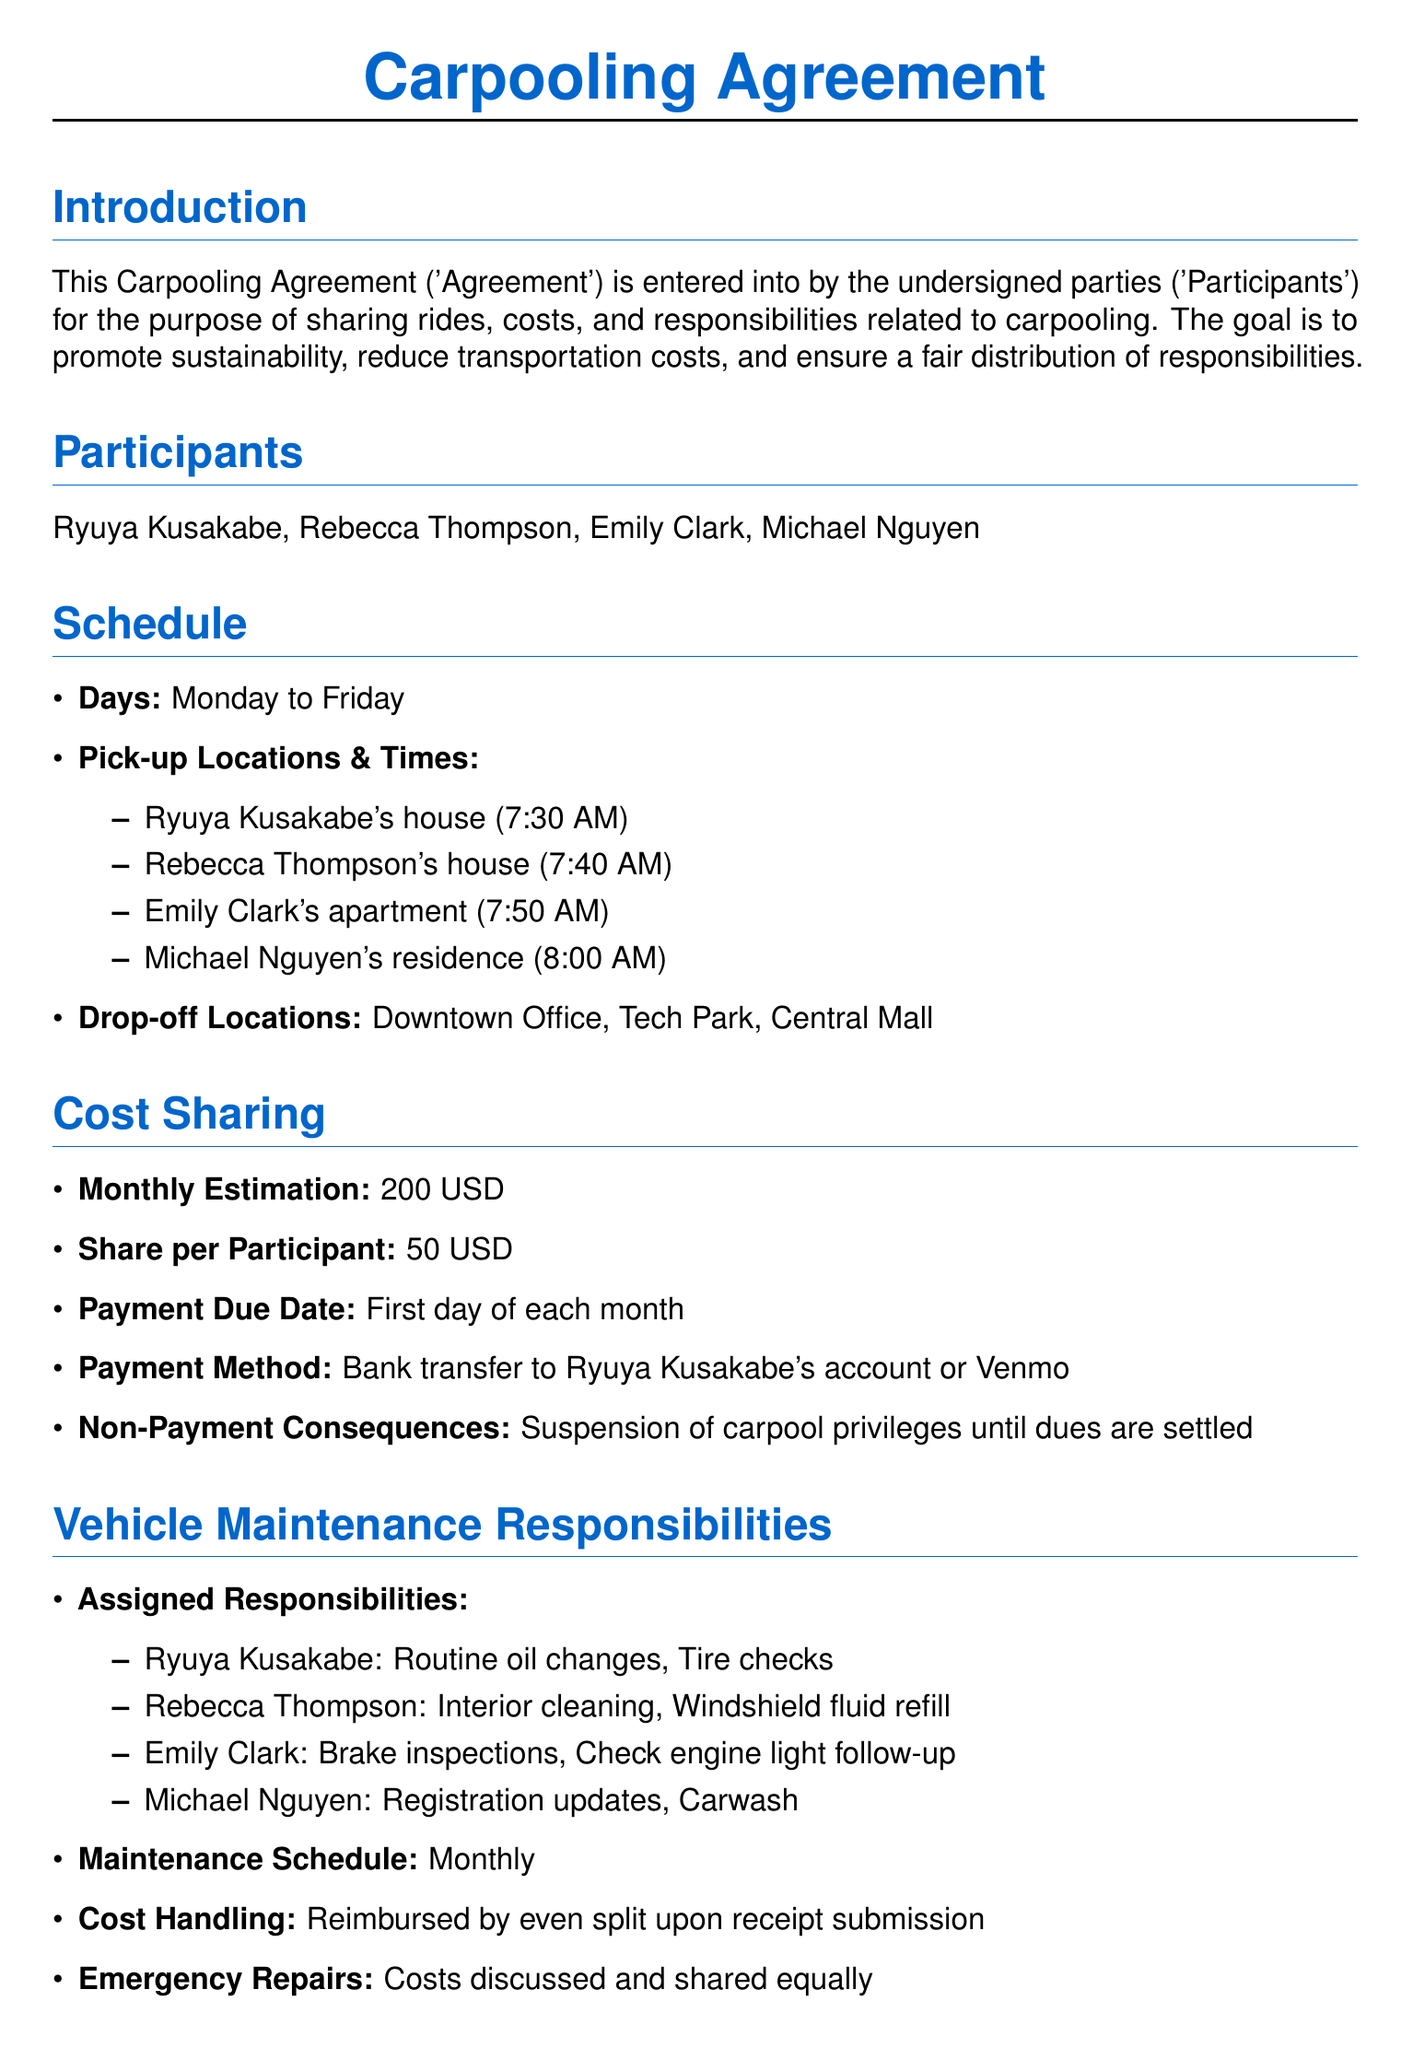What is the title of the document? The title of the document is prominently displayed at the top as "Carpooling Agreement."
Answer: Carpooling Agreement Who are the participants in the carpooling agreement? The participants are listed in the document under the section "Participants."
Answer: Ryuya Kusakabe, Rebecca Thompson, Emily Clark, Michael Nguyen What is the payment due date for cost-sharing? The payment due date is mentioned in the "Cost Sharing" section of the document.
Answer: First day of each month How much is the share per participant? The share per participant is detailed under the "Cost Sharing" section.
Answer: 50 USD What are Ryuya Kusakabe's responsibilities for vehicle maintenance? Ryuya Kusakabe’s responsibilities are listed in the "Vehicle Maintenance Responsibilities."
Answer: Routine oil changes, Tire checks What is the notice period required for termination of the agreement? The notice period is specified in the "Termination Clause" section.
Answer: Two weeks' notice How often is the maintenance schedule? The maintenance schedule's frequency is stated in the "Vehicle Maintenance Responsibilities" section.
Answer: Monthly What is the total monthly cost estimation for the carpooling arrangement? The total monthly cost estimation is given in the "Cost Sharing" part of the document.
Answer: 200 USD 